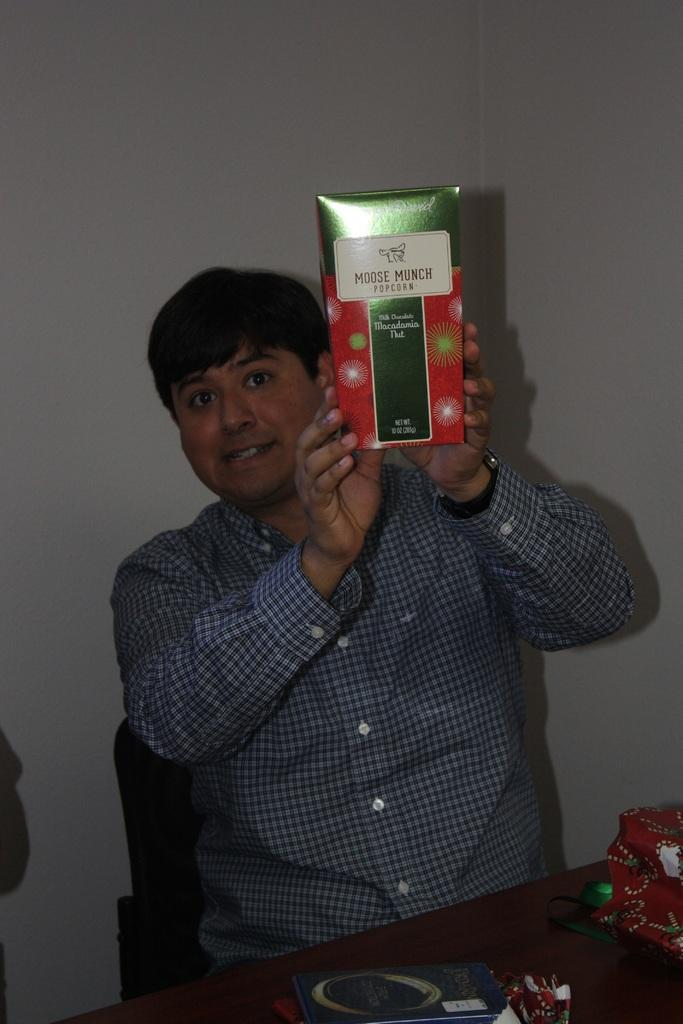<image>
Give a short and clear explanation of the subsequent image. a man is holding an item that says Moose 